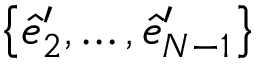Convert formula to latex. <formula><loc_0><loc_0><loc_500><loc_500>\left \{ \hat { e } _ { 2 } ^ { \prime } , \dots , \hat { e } _ { N - 1 } ^ { \prime } \right \}</formula> 